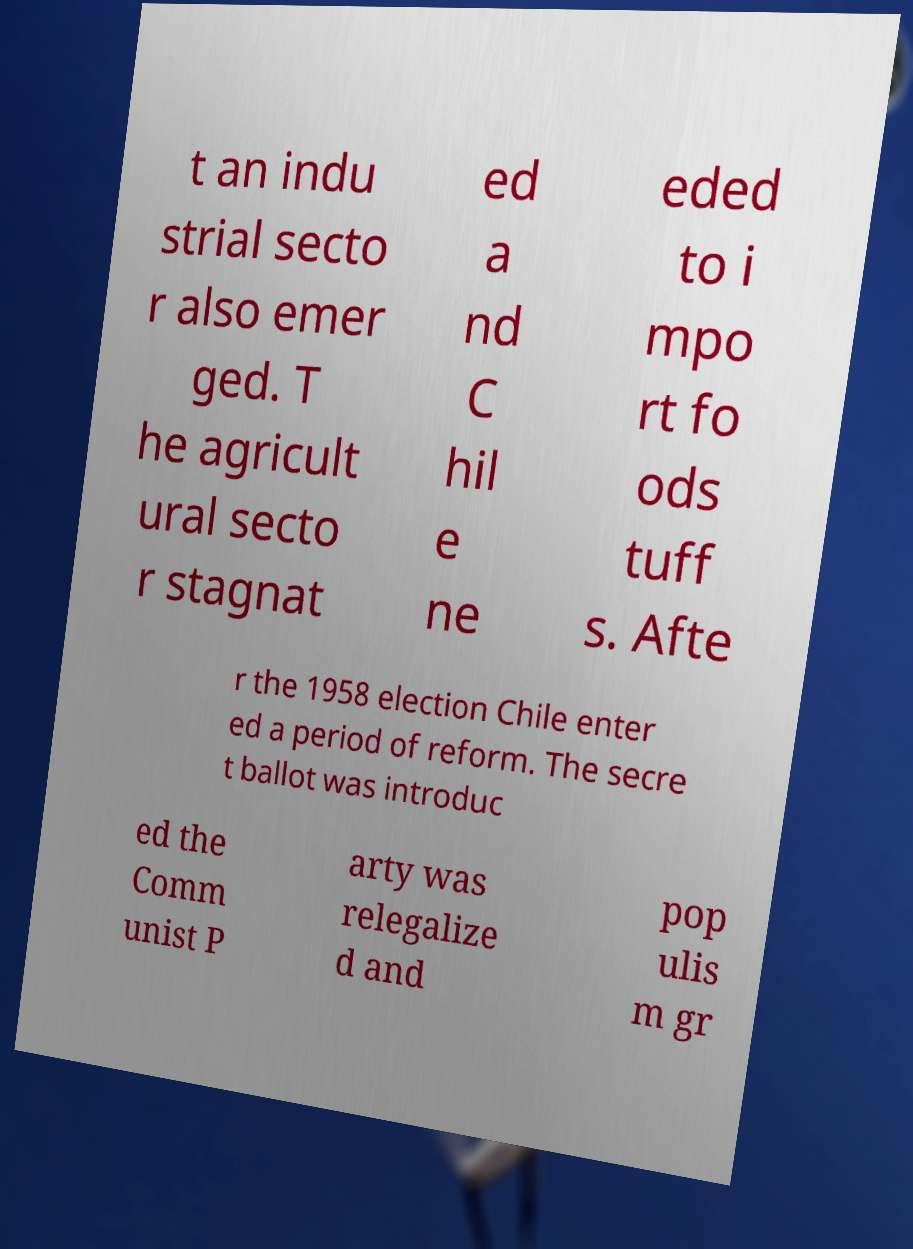Could you assist in decoding the text presented in this image and type it out clearly? t an indu strial secto r also emer ged. T he agricult ural secto r stagnat ed a nd C hil e ne eded to i mpo rt fo ods tuff s. Afte r the 1958 election Chile enter ed a period of reform. The secre t ballot was introduc ed the Comm unist P arty was relegalize d and pop ulis m gr 